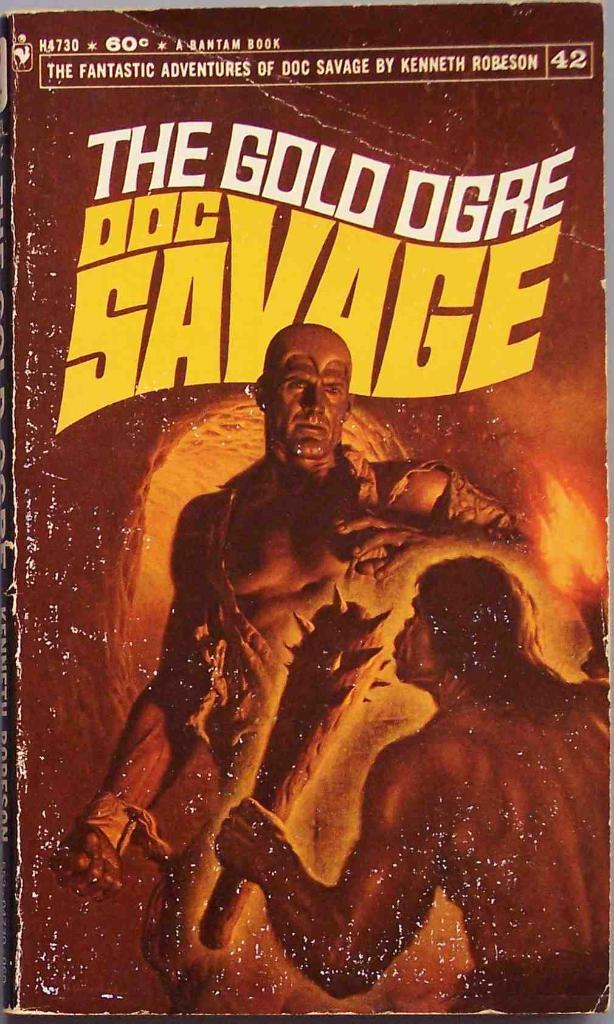What object is present in the image? There is a book in the image. What can be seen on the book? There are people depicted on the book, and there is writing on the book. How many chairs are depicted on the book? There are no chairs depicted on the book; the image only shows a book with people and writing on it. 